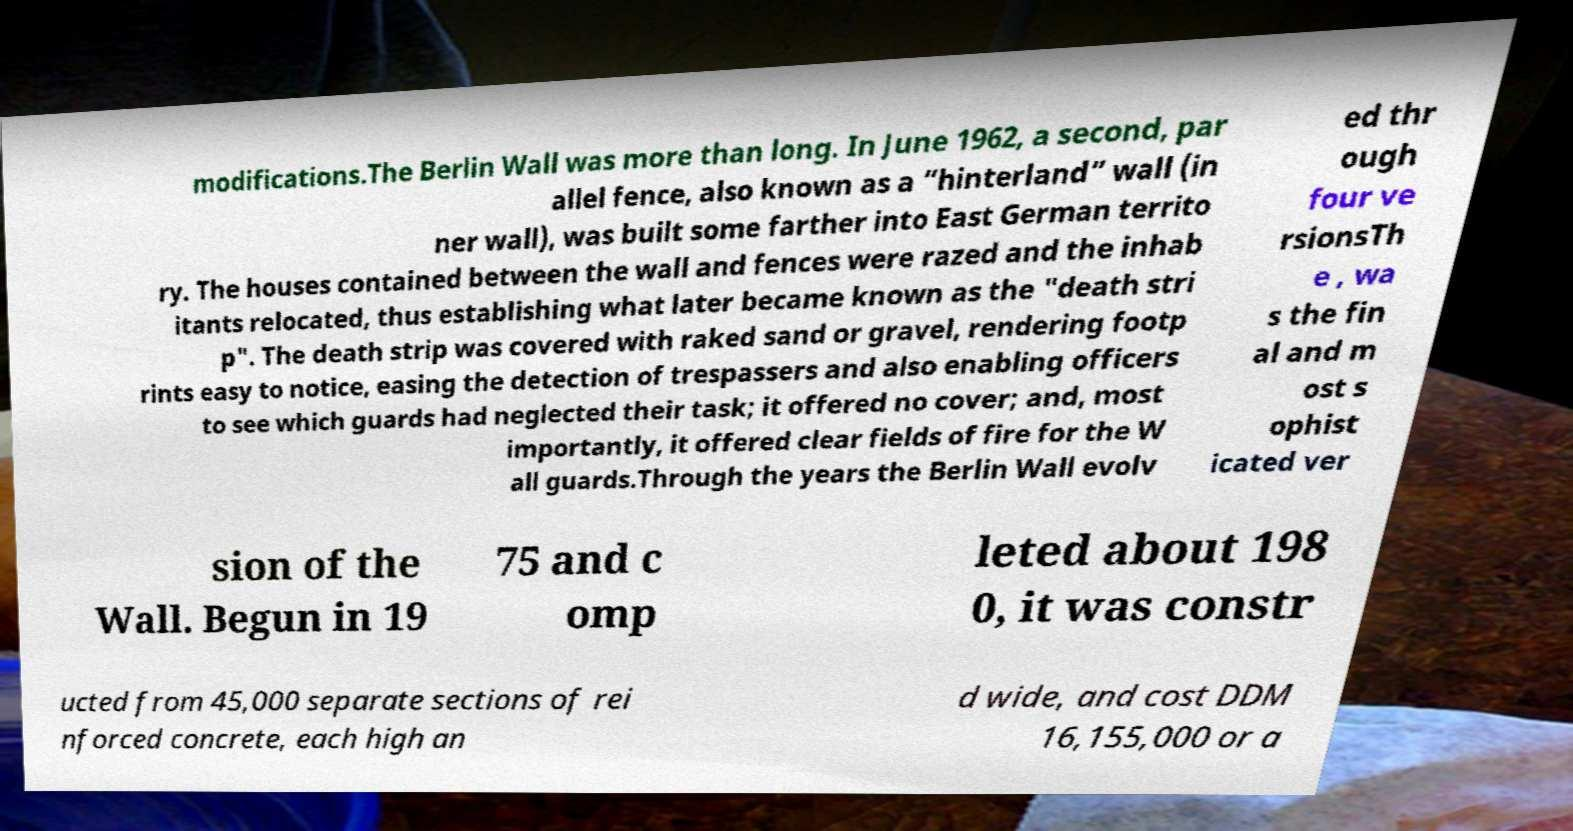Please identify and transcribe the text found in this image. modifications.The Berlin Wall was more than long. In June 1962, a second, par allel fence, also known as a “hinterland” wall (in ner wall), was built some farther into East German territo ry. The houses contained between the wall and fences were razed and the inhab itants relocated, thus establishing what later became known as the "death stri p". The death strip was covered with raked sand or gravel, rendering footp rints easy to notice, easing the detection of trespassers and also enabling officers to see which guards had neglected their task; it offered no cover; and, most importantly, it offered clear fields of fire for the W all guards.Through the years the Berlin Wall evolv ed thr ough four ve rsionsTh e , wa s the fin al and m ost s ophist icated ver sion of the Wall. Begun in 19 75 and c omp leted about 198 0, it was constr ucted from 45,000 separate sections of rei nforced concrete, each high an d wide, and cost DDM 16,155,000 or a 